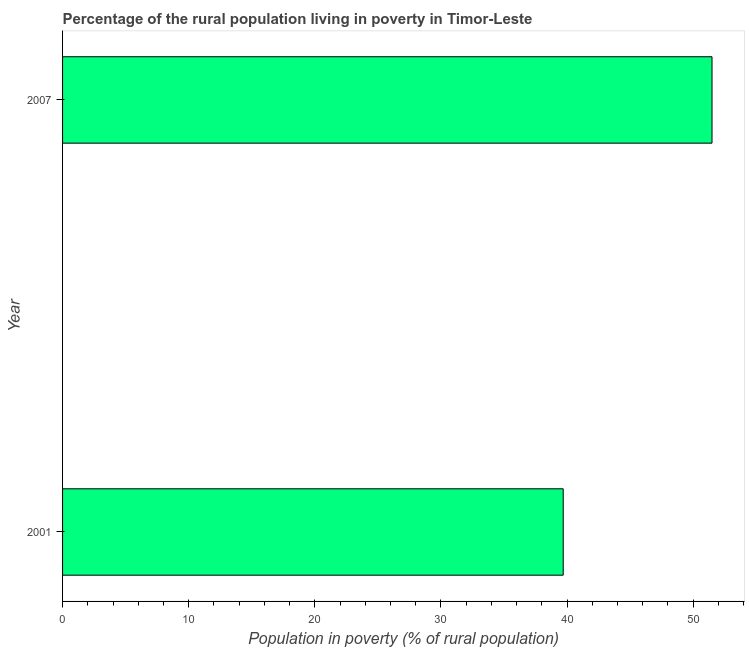Does the graph contain grids?
Provide a short and direct response. No. What is the title of the graph?
Your response must be concise. Percentage of the rural population living in poverty in Timor-Leste. What is the label or title of the X-axis?
Make the answer very short. Population in poverty (% of rural population). What is the label or title of the Y-axis?
Provide a succinct answer. Year. What is the percentage of rural population living below poverty line in 2001?
Provide a short and direct response. 39.7. Across all years, what is the maximum percentage of rural population living below poverty line?
Ensure brevity in your answer.  51.5. Across all years, what is the minimum percentage of rural population living below poverty line?
Your response must be concise. 39.7. In which year was the percentage of rural population living below poverty line maximum?
Keep it short and to the point. 2007. What is the sum of the percentage of rural population living below poverty line?
Offer a very short reply. 91.2. What is the average percentage of rural population living below poverty line per year?
Offer a terse response. 45.6. What is the median percentage of rural population living below poverty line?
Ensure brevity in your answer.  45.6. What is the ratio of the percentage of rural population living below poverty line in 2001 to that in 2007?
Offer a terse response. 0.77. Is the percentage of rural population living below poverty line in 2001 less than that in 2007?
Your answer should be very brief. Yes. How many bars are there?
Your answer should be very brief. 2. Are all the bars in the graph horizontal?
Your answer should be very brief. Yes. How many years are there in the graph?
Ensure brevity in your answer.  2. What is the Population in poverty (% of rural population) of 2001?
Offer a terse response. 39.7. What is the Population in poverty (% of rural population) in 2007?
Give a very brief answer. 51.5. What is the ratio of the Population in poverty (% of rural population) in 2001 to that in 2007?
Offer a very short reply. 0.77. 